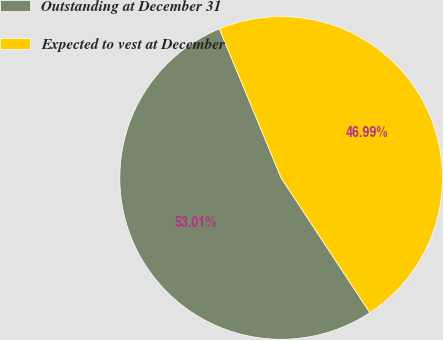Convert chart. <chart><loc_0><loc_0><loc_500><loc_500><pie_chart><fcel>Outstanding at December 31<fcel>Expected to vest at December<nl><fcel>53.01%<fcel>46.99%<nl></chart> 